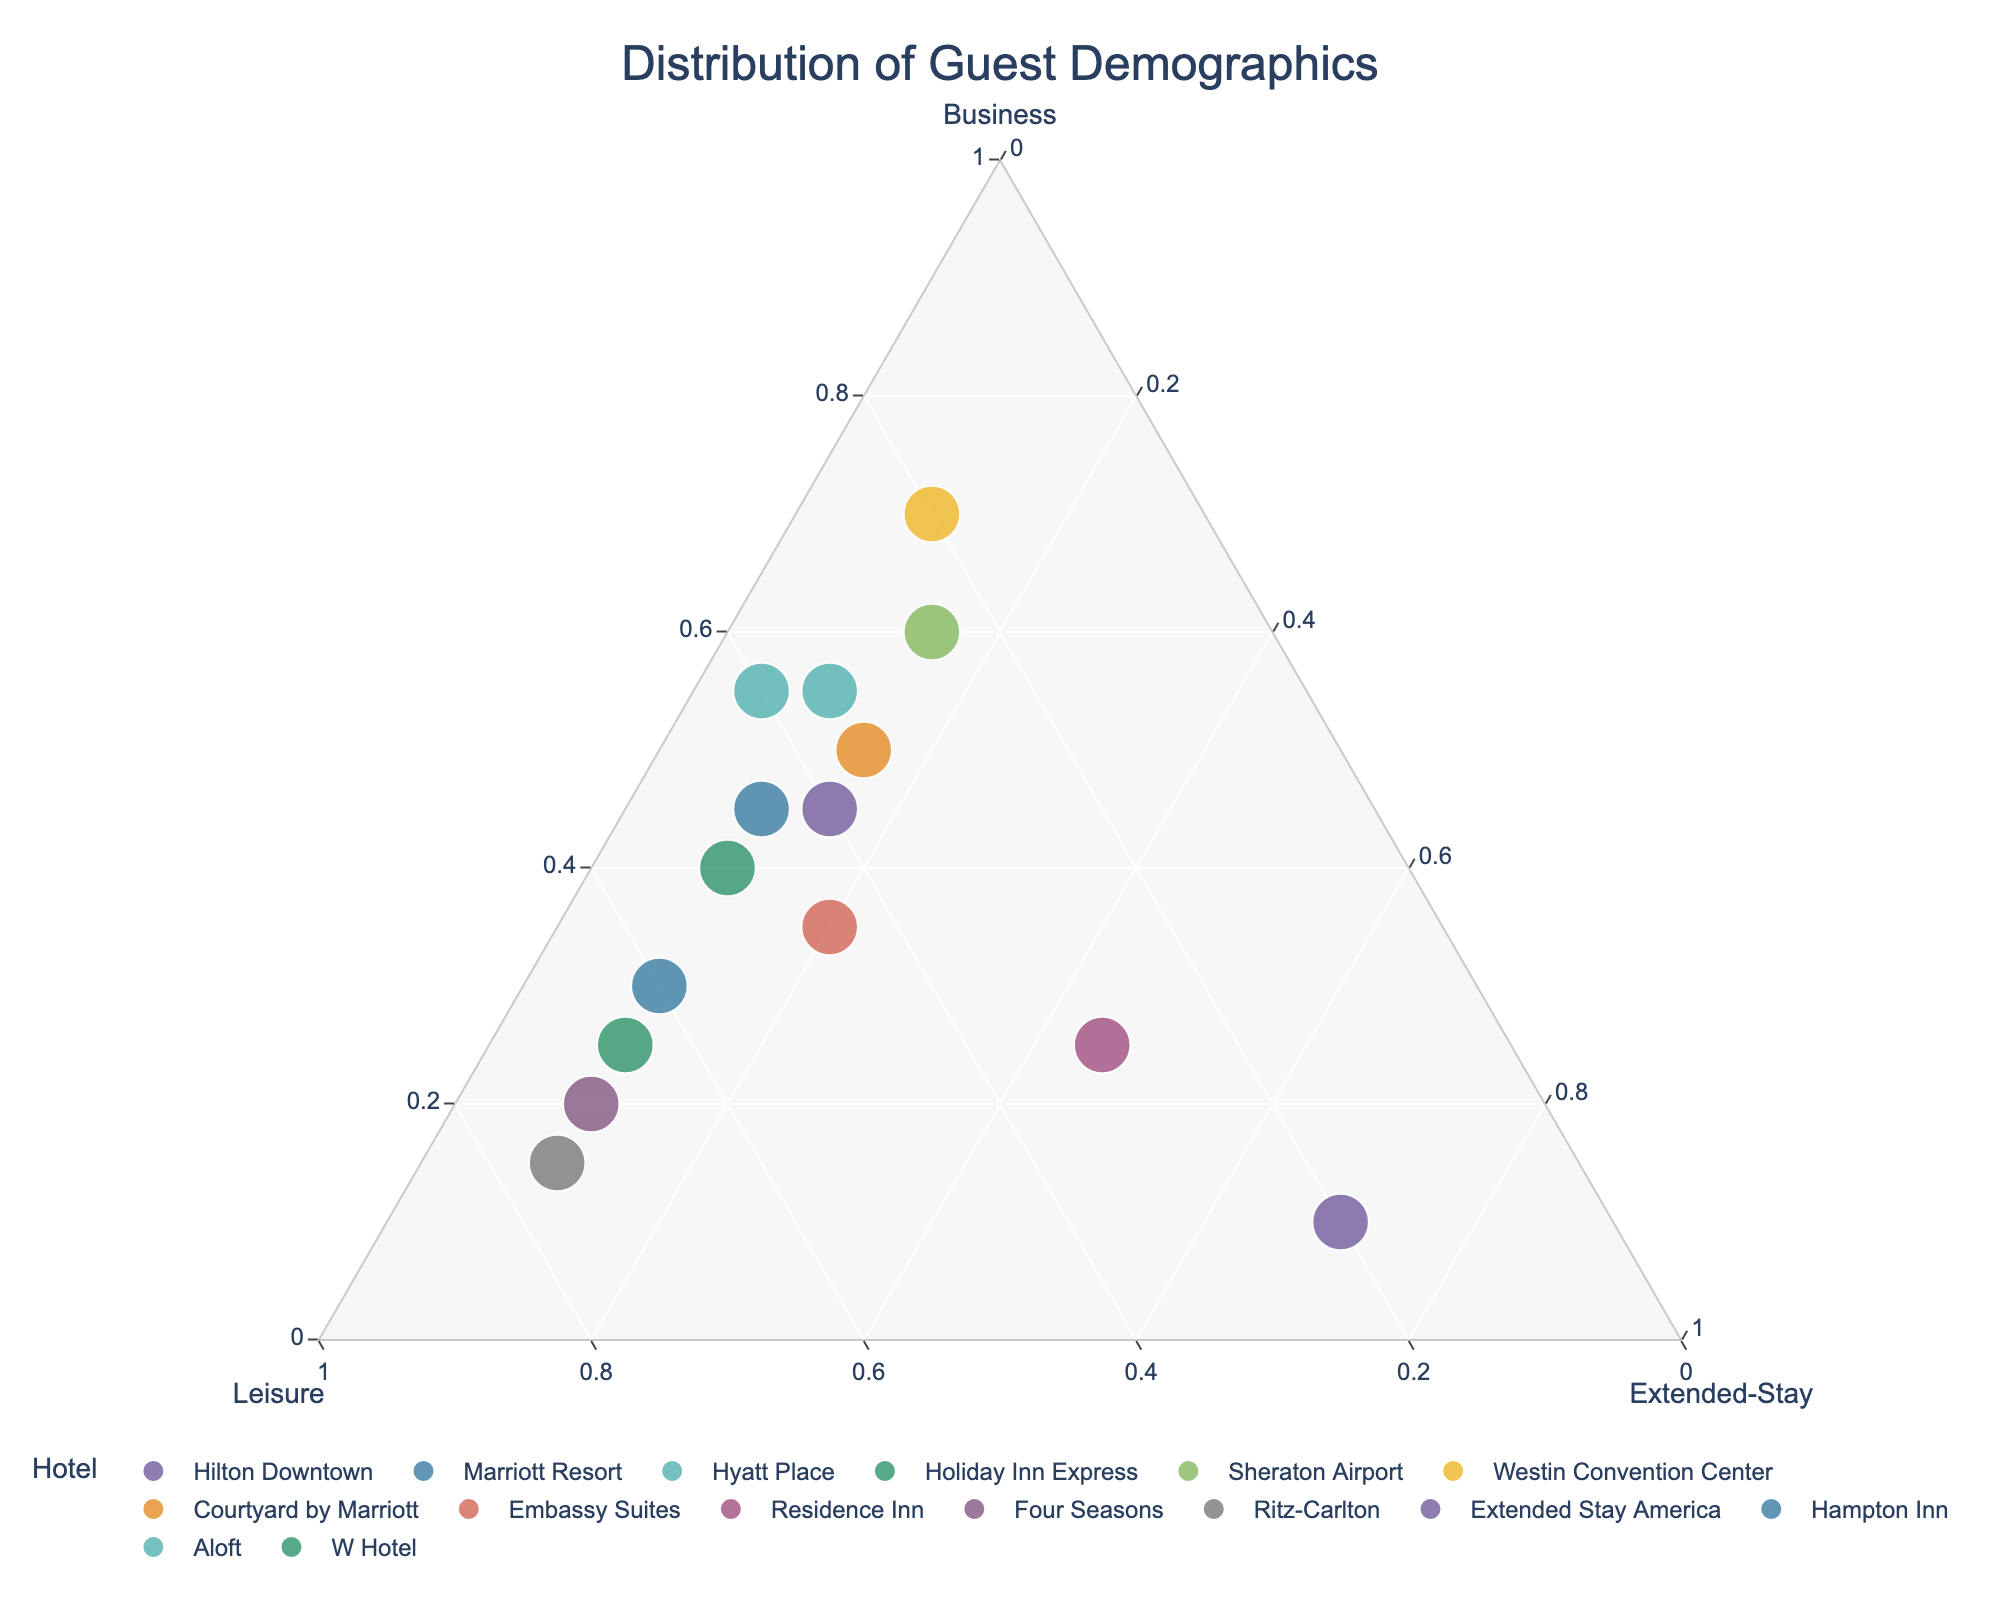What is the title of the figure? The title of the figure is typically displayed at the top center and provides a summary of what the plot represents. In this case, it reads "Distribution of Guest Demographics".
Answer: Distribution of Guest Demographics How many hotels are represented in the plot? To determine the number of hotels, count the individual data points or hover texts each representing a hotel. There are 15 hotels listed in the provided data.
Answer: 15 Which hotel has the highest proportion of business travelers? To find this, look for the point closest to the Business axis. The hotel with the highest proportion of business travelers is the Westin Convention Center with 70% of its guests being business travelers.
Answer: Westin Convention Center Are there any hotels with a perfectly balanced number of business and leisure travelers? This involves finding points where the proportions of business and leisure travelers are equal. The Hampton Inn has equal proportions of business and leisure travelers (both at 45%).
Answer: Hampton Inn Which two hotels have the closest proportions of leisure travelers? To answer this, look for points that are close to each other along the Leisure axis. The Ritz-Carlton and Four Seasons have very close proportions of leisure travelers, with Ritz-Carlton at 75% and Four Seasons at 70%.
Answer: Ritz-Carlton and Four Seasons Which hotel has the highest proportion of extended-stay guests? Look for the hotel closest to the Extended-Stay axis. Extended Stay America has the highest proportion of extended-stay guests at 70%.
Answer: Extended Stay America Compare the Hilton Downtown and Hyatt Place. Which hotel has a higher proportion of leisure travelers? Locate both hotels in the plot and see which one is closer to the Leisure axis. Hilton Downtown has 40%, whereas Hyatt Place has 35%, so Hilton Downtown has a higher proportion of leisure travelers.
Answer: Hilton Downtown What is the median value of business travelers across all hotels? Arrange the business traveler proportions in ascending order: 10, 15, 20, 30, 25, 25, 30, 35, 40, 45, 45, 50, 55, 55, 60, and find the median of these values. The median corresponds to the middle value in the sorted list (35).
Answer: 40 Which hotel has the lowest proportion of business travelers? Identify the hotel closest to the Leisure axis. The Ritz-Carlton, with only 15% business travelers, has the lowest proportion.
Answer: Ritz-Carlton Is there any hotel that has all three guest types nearly equally balanced? Check for points located centrally in the plot where the proportions of Business, Leisure, and Extended-Stay travelers are near each other. No hotel has all three guest types nearly equally balanced as per the given data.
Answer: No 